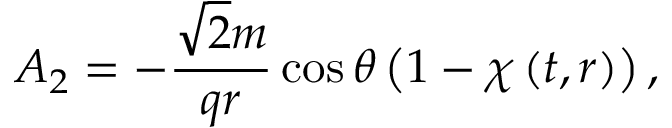<formula> <loc_0><loc_0><loc_500><loc_500>A _ { 2 } = - \frac { \sqrt { 2 } m } { q r } \cos \theta \left ( 1 - \chi \left ( t , r \right ) \right ) ,</formula> 